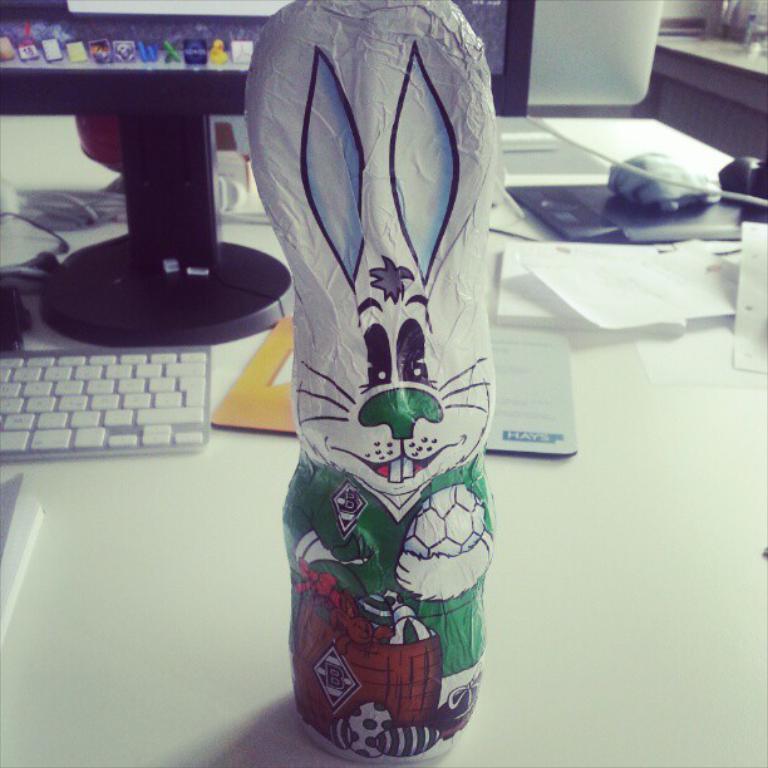Can you describe this image briefly? A toy is on a table with a keyboard and monitor behind it. 